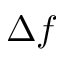<formula> <loc_0><loc_0><loc_500><loc_500>\Delta f</formula> 